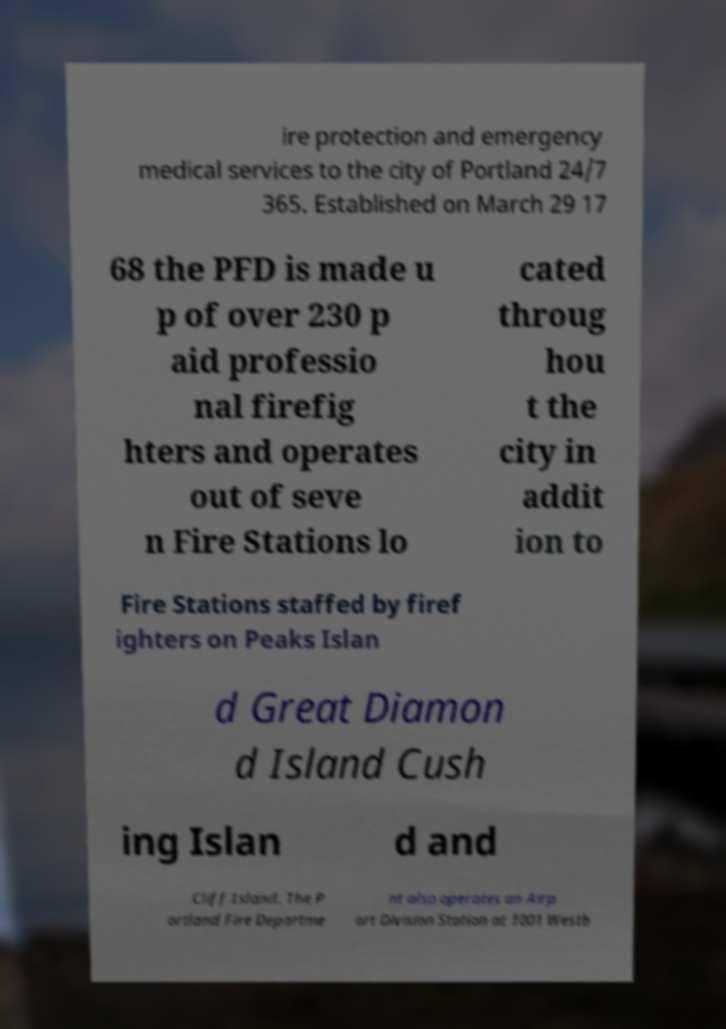Could you assist in decoding the text presented in this image and type it out clearly? ire protection and emergency medical services to the city of Portland 24/7 365. Established on March 29 17 68 the PFD is made u p of over 230 p aid professio nal firefig hters and operates out of seve n Fire Stations lo cated throug hou t the city in addit ion to Fire Stations staffed by firef ighters on Peaks Islan d Great Diamon d Island Cush ing Islan d and Cliff Island. The P ortland Fire Departme nt also operates an Airp ort Division Station at 1001 Westb 